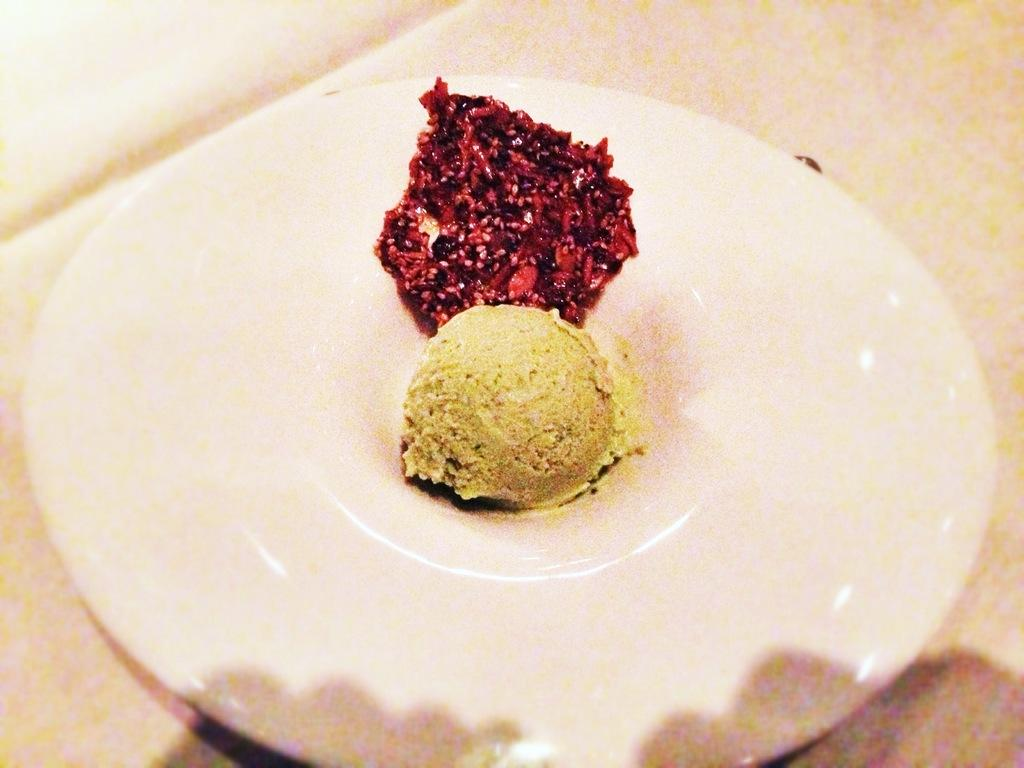What is the main subject in the center of the image? There is a plate with food items in the center of the image. What is the location of the table in the image? The table is at the bottom of the image. How many visitors can be seen wearing underwear in the image? There are no visitors or underwear present in the image. 